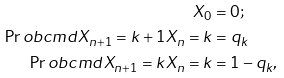Convert formula to latex. <formula><loc_0><loc_0><loc_500><loc_500>X _ { 0 } & = 0 ; \\ \Pr o b c m d { X _ { n + 1 } = k + 1 } { X _ { n } = k } & = q _ { k } \\ \Pr o b c m d { X _ { n + 1 } = k } { X _ { n } = k } & = 1 - q _ { k } ,</formula> 